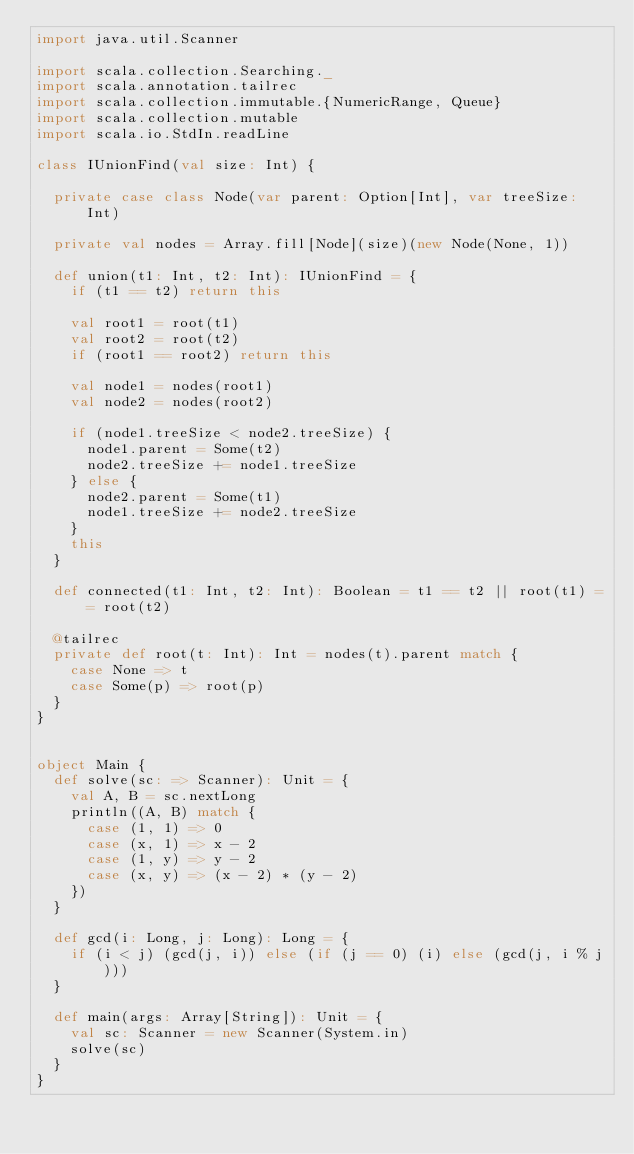Convert code to text. <code><loc_0><loc_0><loc_500><loc_500><_Scala_>import java.util.Scanner

import scala.collection.Searching._
import scala.annotation.tailrec
import scala.collection.immutable.{NumericRange, Queue}
import scala.collection.mutable
import scala.io.StdIn.readLine

class IUnionFind(val size: Int) {

  private case class Node(var parent: Option[Int], var treeSize: Int)

  private val nodes = Array.fill[Node](size)(new Node(None, 1))

  def union(t1: Int, t2: Int): IUnionFind = {
    if (t1 == t2) return this

    val root1 = root(t1)
    val root2 = root(t2)
    if (root1 == root2) return this

    val node1 = nodes(root1)
    val node2 = nodes(root2)

    if (node1.treeSize < node2.treeSize) {
      node1.parent = Some(t2)
      node2.treeSize += node1.treeSize
    } else {
      node2.parent = Some(t1)
      node1.treeSize += node2.treeSize
    }
    this
  }

  def connected(t1: Int, t2: Int): Boolean = t1 == t2 || root(t1) == root(t2)

  @tailrec
  private def root(t: Int): Int = nodes(t).parent match {
    case None => t
    case Some(p) => root(p)
  }
}


object Main {
  def solve(sc: => Scanner): Unit = {
    val A, B = sc.nextLong
    println((A, B) match {
      case (1, 1) => 0
      case (x, 1) => x - 2
      case (1, y) => y - 2
      case (x, y) => (x - 2) * (y - 2)
    })
  }

  def gcd(i: Long, j: Long): Long = {
    if (i < j) (gcd(j, i)) else (if (j == 0) (i) else (gcd(j, i % j)))
  }

  def main(args: Array[String]): Unit = {
    val sc: Scanner = new Scanner(System.in)
    solve(sc)
  }
}</code> 